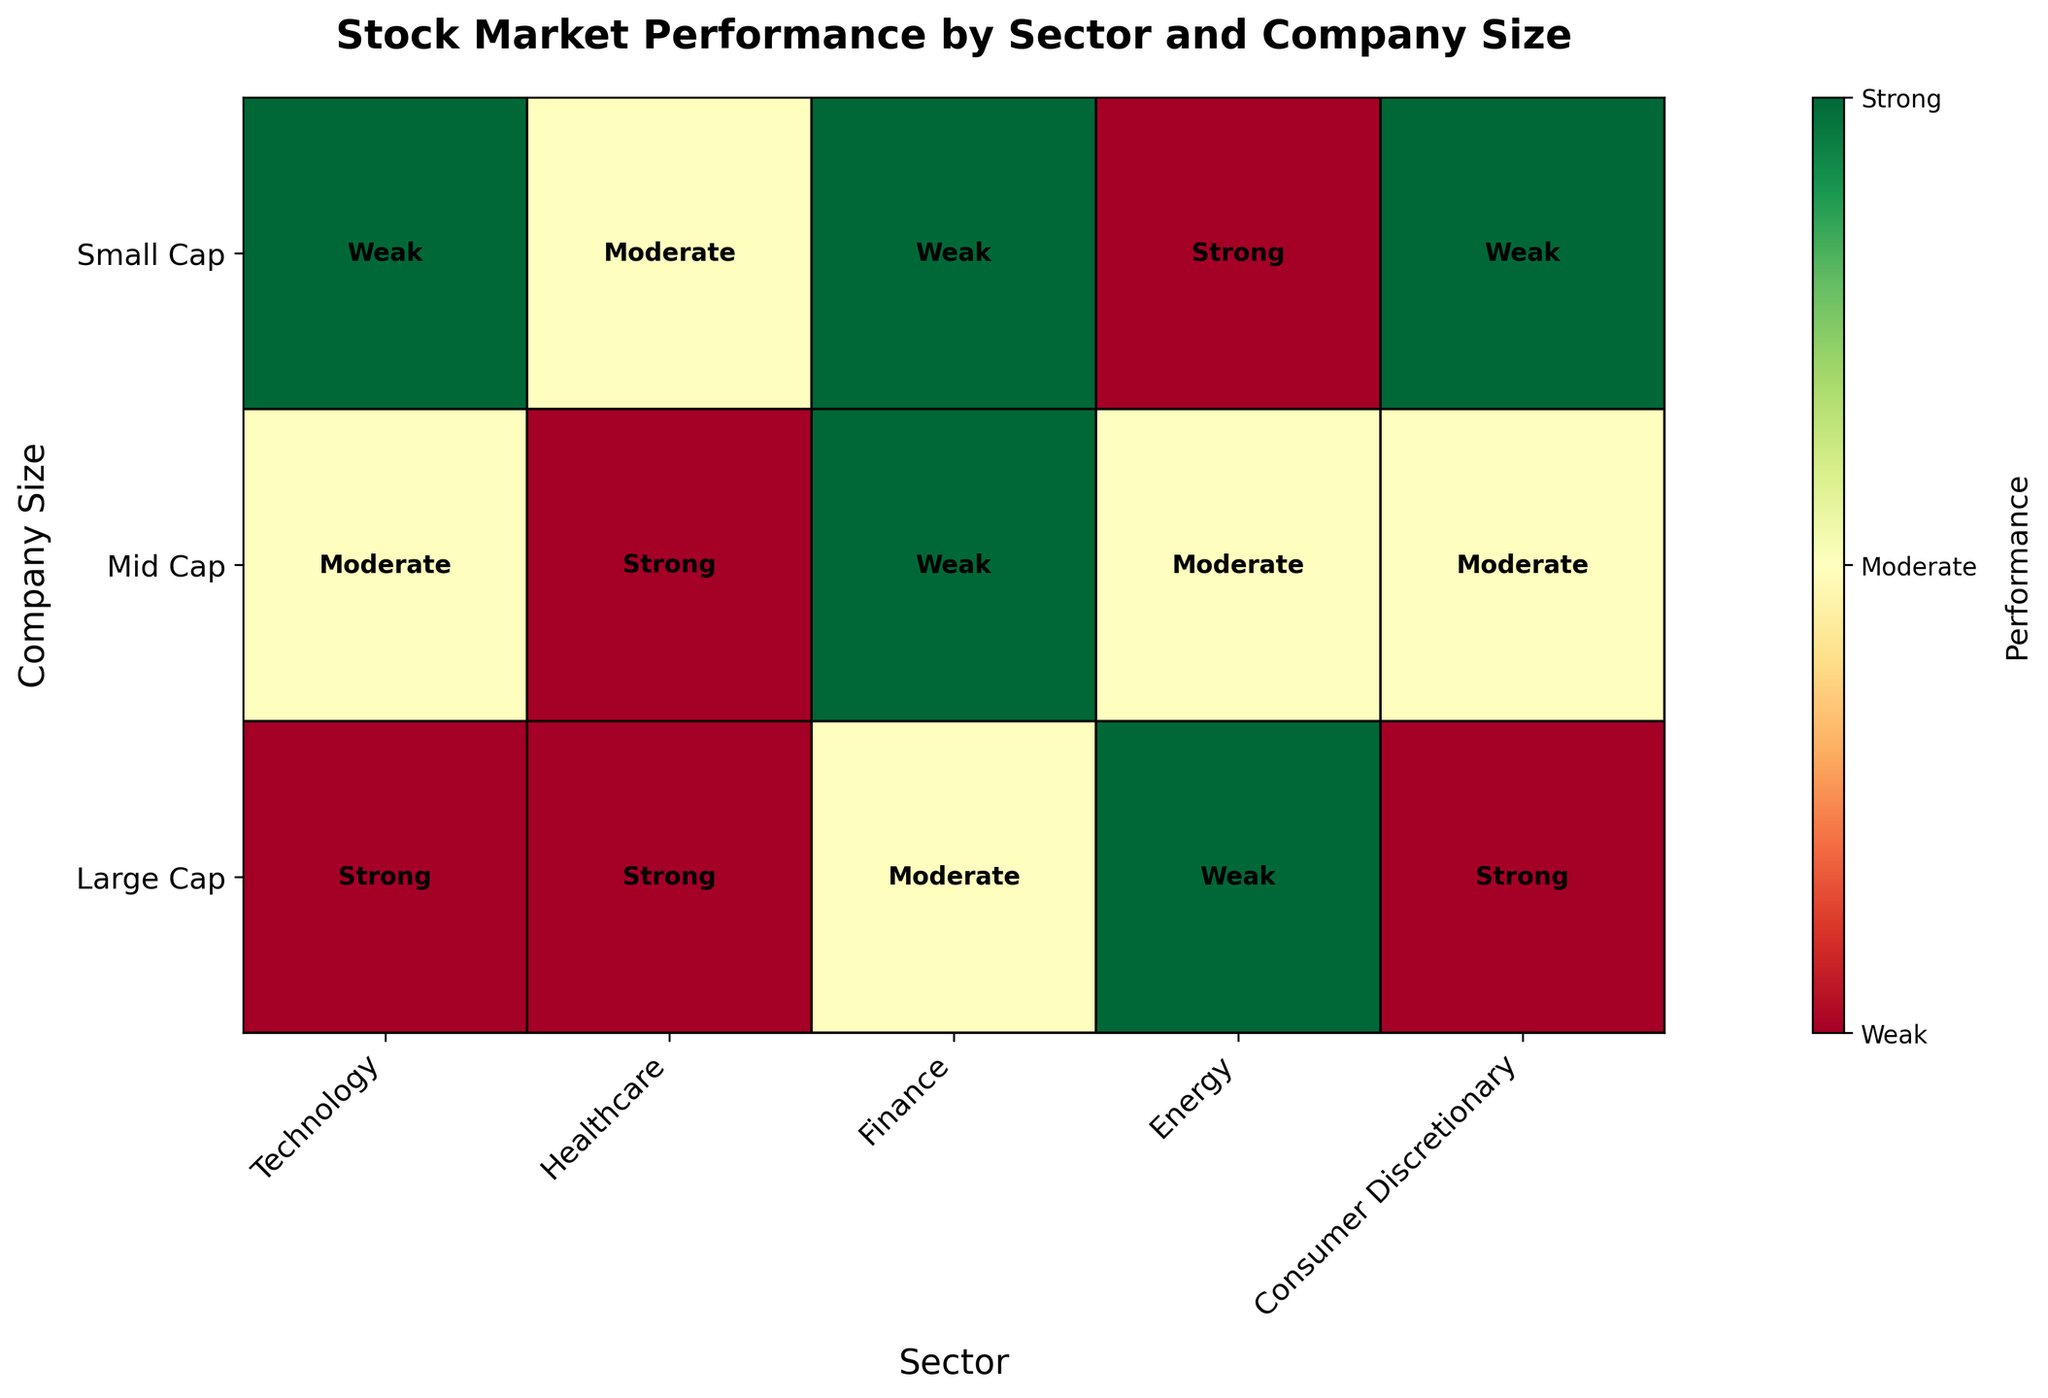What is the title of the figure? The title is prominently displayed at the top of the figure to provide a summary of what the plot represents.
Answer: Stock Market Performance by Sector and Company Size Which sector has the weakest performance in all company sizes? By looking at the colors representing weak performance (typically red) across all company sizes, we can identify the sector.
Answer: Finance How many sectors have at least one company with strong performance? Checking for the color representing strong performance (typically green) in each sector reveals the sectors with at least one strong performance.
Answer: Four What is the performance of large-cap companies in the Technology sector? Locate the intersection of the Technology sector and large-cap companies, noting the color and label.
Answer: Strong Compare the performance of mid-cap companies between the Finance and Healthcare sectors. Which is better? Locate the mid-cap row for both Finance and Healthcare sectors and compare their colors and labels.
Answer: Healthcare Which company size shows the most variability in performance across different sectors? Scan all sizes across sectors to identify the one with the most distinct colors (green, yellow, red).
Answer: Small Cap In which sector do small-cap companies have the strongest performance? Find small-cap companies across all sectors and identify the sector with green color or strong label.
Answer: Energy Compare the performance of mid-cap companies in the Energy and Consumer Discretionary sectors. Which one performs better? Look at the mid-cap row for both Energy and Consumer Discretionary sectors and compare colors and labels.
Answer: Energy Is there any sector where all company sizes have a weak performance? Scan all company sizes within each sector to see if they are consistently marked with the weak performance color (typically red).
Answer: No What's the overall performance trend for large-cap companies across all sectors? Check the colors and labels for large-cap companies in each sector and summarize the common performance level.
Answer: Mostly Strong 